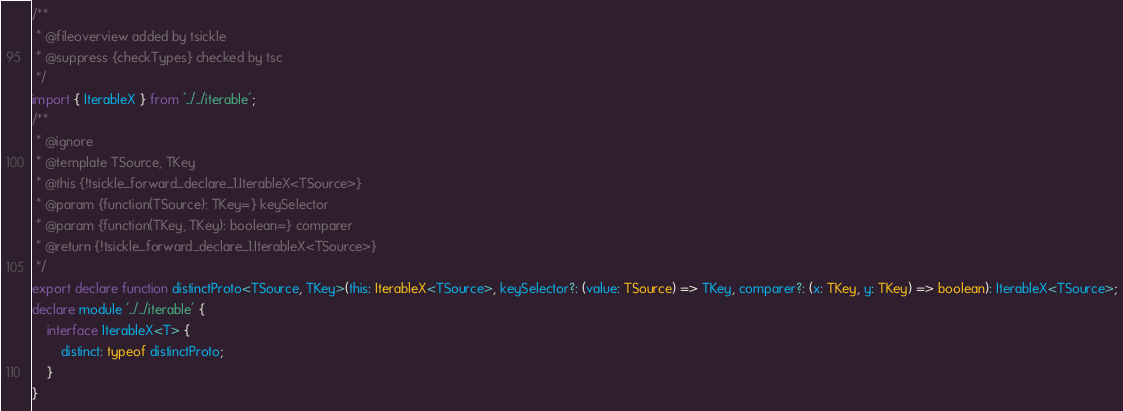Convert code to text. <code><loc_0><loc_0><loc_500><loc_500><_TypeScript_>/**
 * @fileoverview added by tsickle
 * @suppress {checkTypes} checked by tsc
 */
import { IterableX } from '../../iterable';
/**
 * @ignore
 * @template TSource, TKey
 * @this {!tsickle_forward_declare_1.IterableX<TSource>}
 * @param {function(TSource): TKey=} keySelector
 * @param {function(TKey, TKey): boolean=} comparer
 * @return {!tsickle_forward_declare_1.IterableX<TSource>}
 */
export declare function distinctProto<TSource, TKey>(this: IterableX<TSource>, keySelector?: (value: TSource) => TKey, comparer?: (x: TKey, y: TKey) => boolean): IterableX<TSource>;
declare module '../../iterable' {
    interface IterableX<T> {
        distinct: typeof distinctProto;
    }
}
</code> 